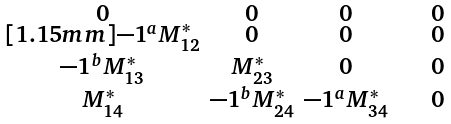Convert formula to latex. <formula><loc_0><loc_0><loc_500><loc_500>\begin{smallmatrix} \\ 0 & 0 & 0 & \quad 0 \quad \\ [ 1 . 1 5 m m ] - 1 ^ { a } M _ { 1 2 } ^ { * } & 0 & 0 & 0 \\ - 1 ^ { b } M _ { 1 3 } ^ { * } & M _ { 2 3 } ^ { * } & 0 & 0 \\ M _ { 1 4 } ^ { * } & - 1 ^ { b } M _ { 2 4 } ^ { * } & - 1 ^ { a } M _ { 3 4 } ^ { * } & 0 \\ \end{smallmatrix}</formula> 